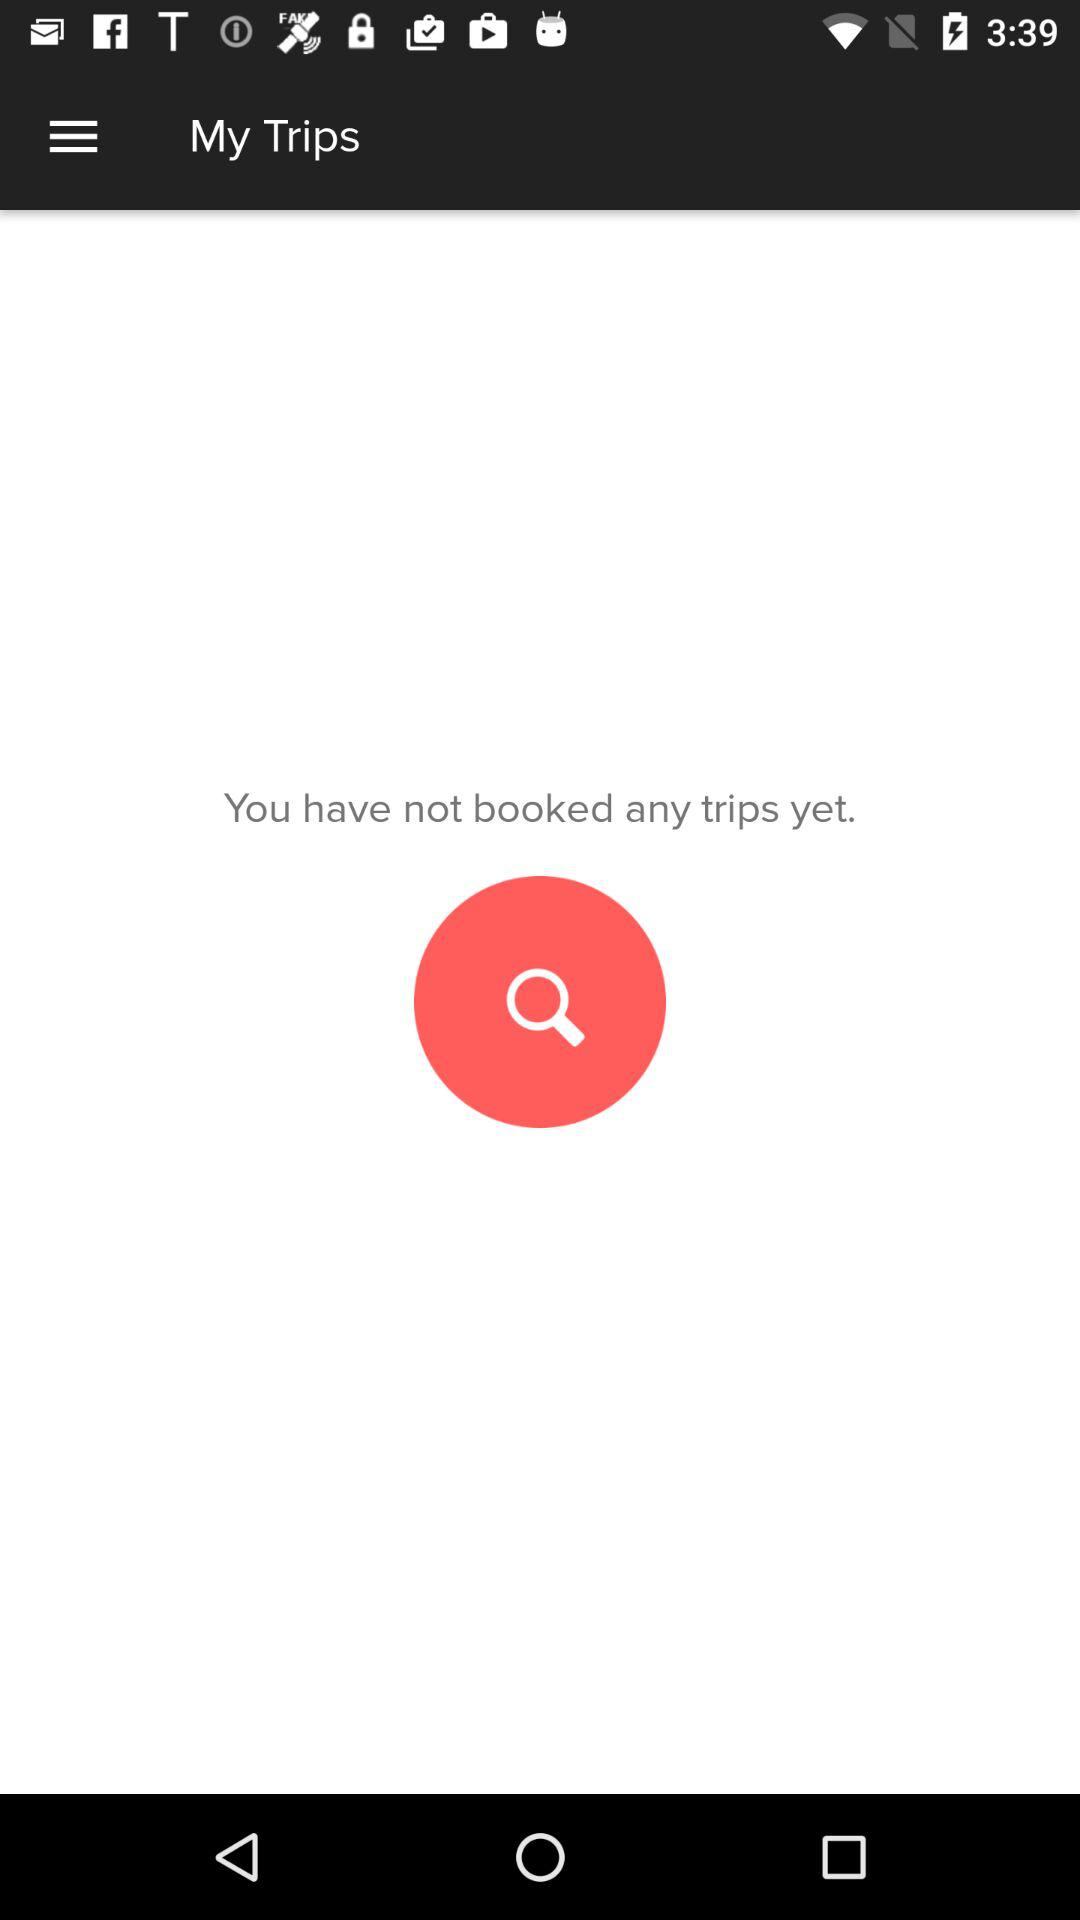Is there any booking? There is no booking. 